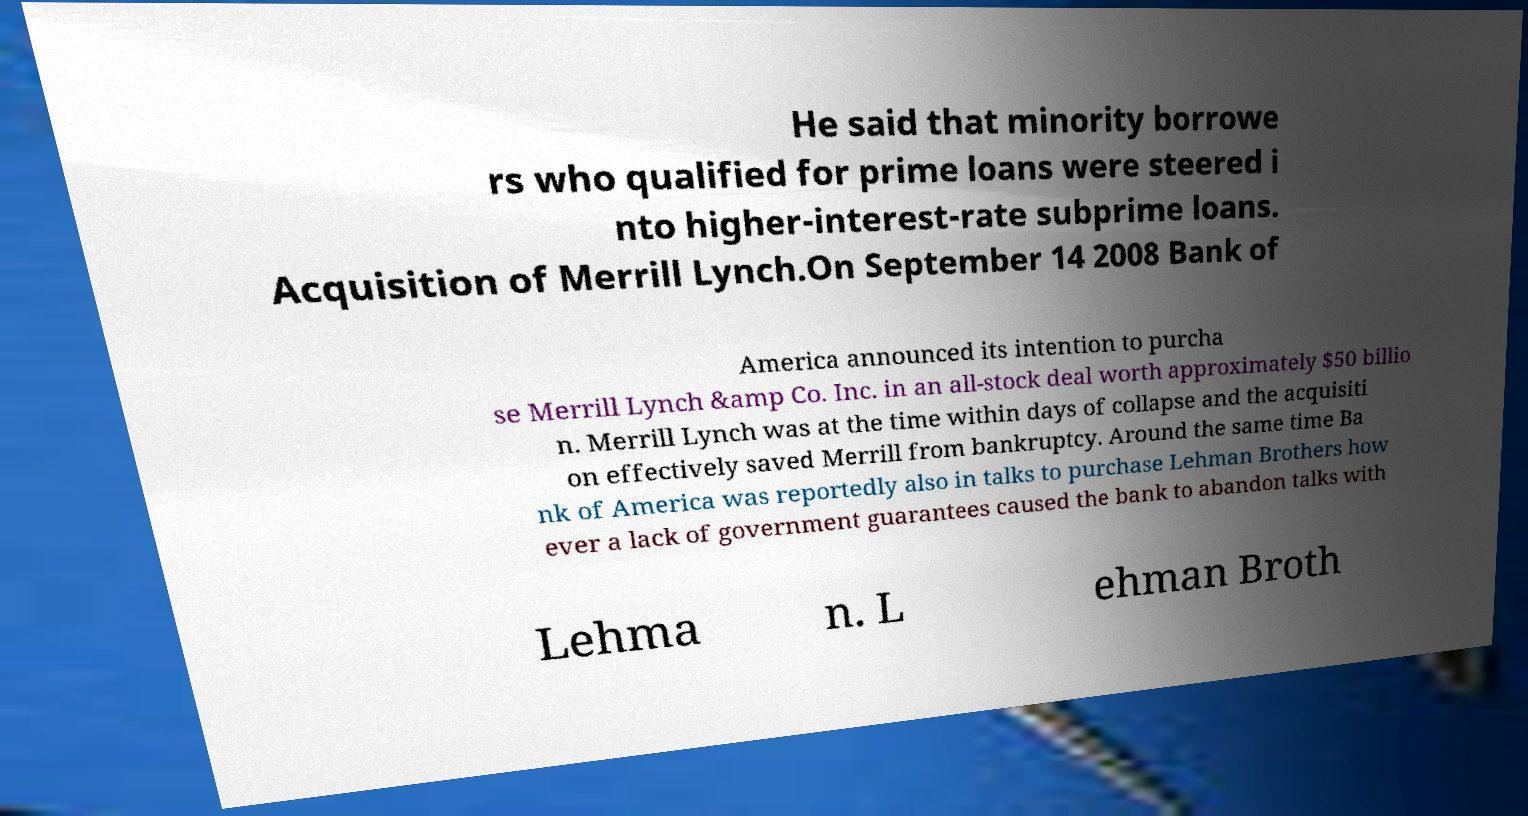Please read and relay the text visible in this image. What does it say? He said that minority borrowe rs who qualified for prime loans were steered i nto higher-interest-rate subprime loans. Acquisition of Merrill Lynch.On September 14 2008 Bank of America announced its intention to purcha se Merrill Lynch &amp Co. Inc. in an all-stock deal worth approximately $50 billio n. Merrill Lynch was at the time within days of collapse and the acquisiti on effectively saved Merrill from bankruptcy. Around the same time Ba nk of America was reportedly also in talks to purchase Lehman Brothers how ever a lack of government guarantees caused the bank to abandon talks with Lehma n. L ehman Broth 